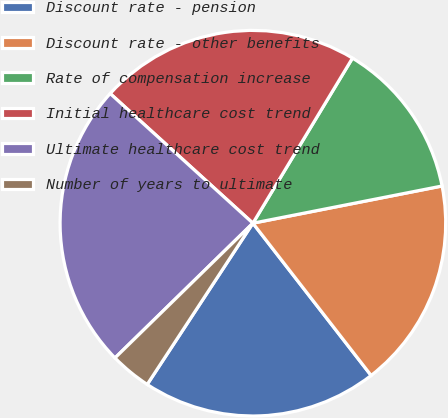Convert chart to OTSL. <chart><loc_0><loc_0><loc_500><loc_500><pie_chart><fcel>Discount rate - pension<fcel>Discount rate - other benefits<fcel>Rate of compensation increase<fcel>Initial healthcare cost trend<fcel>Ultimate healthcare cost trend<fcel>Number of years to ultimate<nl><fcel>19.74%<fcel>17.58%<fcel>13.27%<fcel>21.9%<fcel>24.05%<fcel>3.45%<nl></chart> 